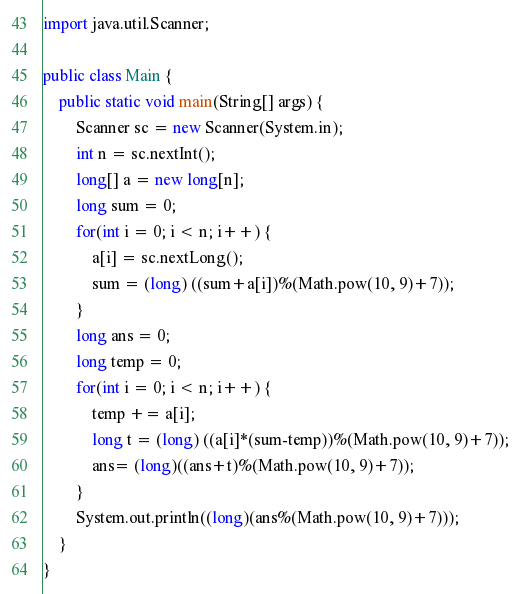<code> <loc_0><loc_0><loc_500><loc_500><_Java_>import java.util.Scanner;

public class Main {
	public static void main(String[] args) {
		Scanner sc = new Scanner(System.in);
		int n = sc.nextInt();
		long[] a = new long[n];
		long sum = 0;
		for(int i = 0; i < n; i++) {
			a[i] = sc.nextLong();
			sum = (long) ((sum+a[i])%(Math.pow(10, 9)+7));
		}
		long ans = 0;
		long temp = 0;
		for(int i = 0; i < n; i++) {
			temp += a[i];
			long t = (long) ((a[i]*(sum-temp))%(Math.pow(10, 9)+7));
			ans= (long)((ans+t)%(Math.pow(10, 9)+7));
		}
		System.out.println((long)(ans%(Math.pow(10, 9)+7)));
	}
}</code> 